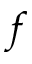<formula> <loc_0><loc_0><loc_500><loc_500>f</formula> 